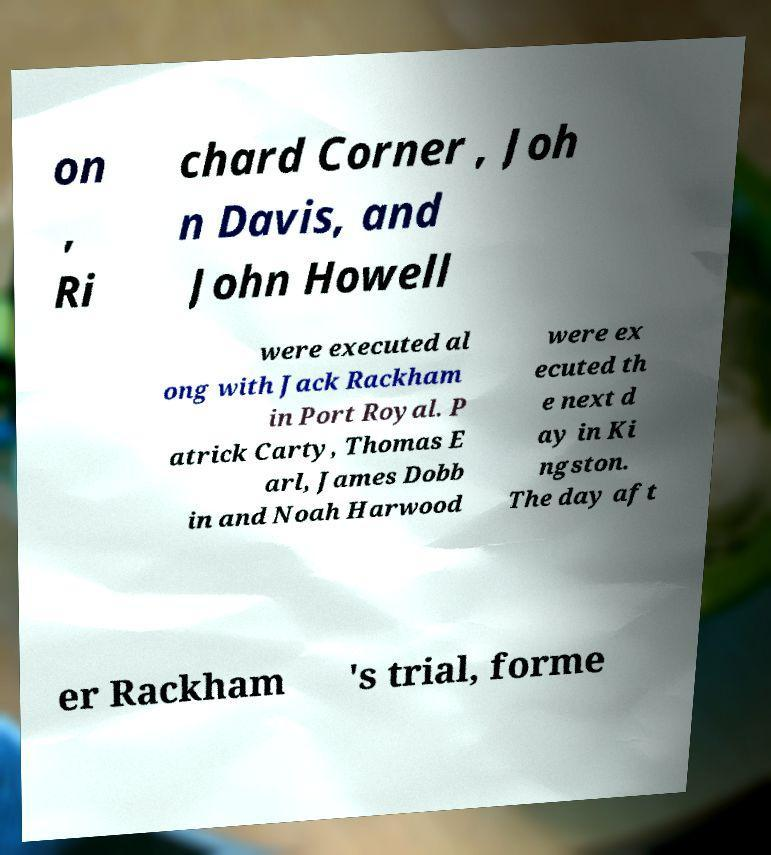Please identify and transcribe the text found in this image. on , Ri chard Corner , Joh n Davis, and John Howell were executed al ong with Jack Rackham in Port Royal. P atrick Carty, Thomas E arl, James Dobb in and Noah Harwood were ex ecuted th e next d ay in Ki ngston. The day aft er Rackham 's trial, forme 